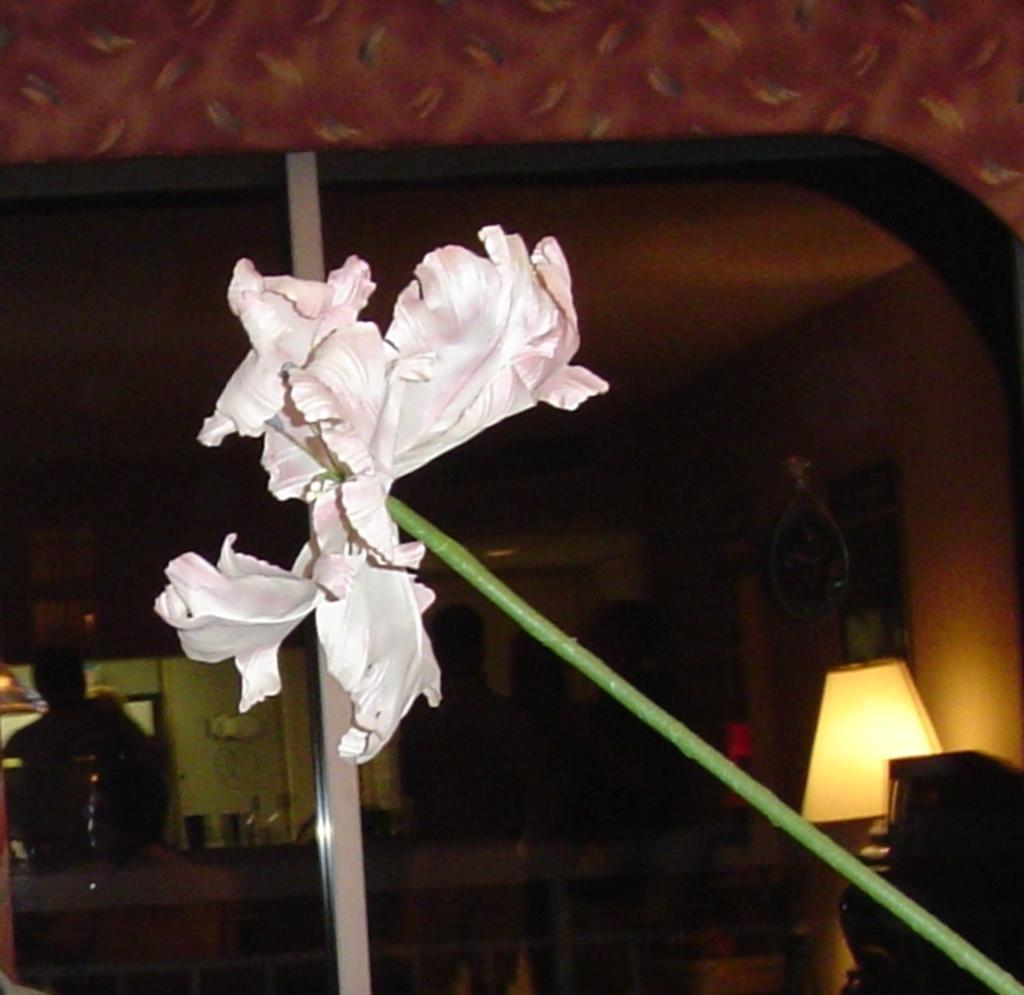What is one of the main subjects in the image? There is a flower in the image. What other object can be seen in the image? There is a lamp in the image. What can be found on the right side of the image? There are other objects on the right side of the image. Can you describe the background of the image? There are people visible in the background of the image, along with other things. What is the opinion of the yak in the image? There is no yak present in the image, so it is not possible to determine its opinion. 